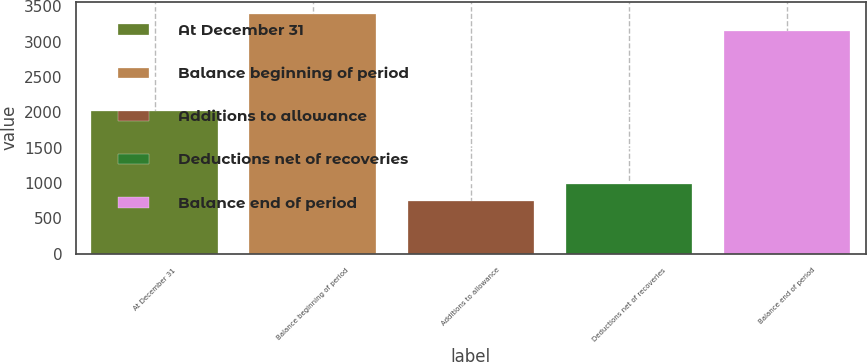<chart> <loc_0><loc_0><loc_500><loc_500><bar_chart><fcel>At December 31<fcel>Balance beginning of period<fcel>Additions to allowance<fcel>Deductions net of recoveries<fcel>Balance end of period<nl><fcel>2014<fcel>3395.2<fcel>748<fcel>993.2<fcel>3150<nl></chart> 